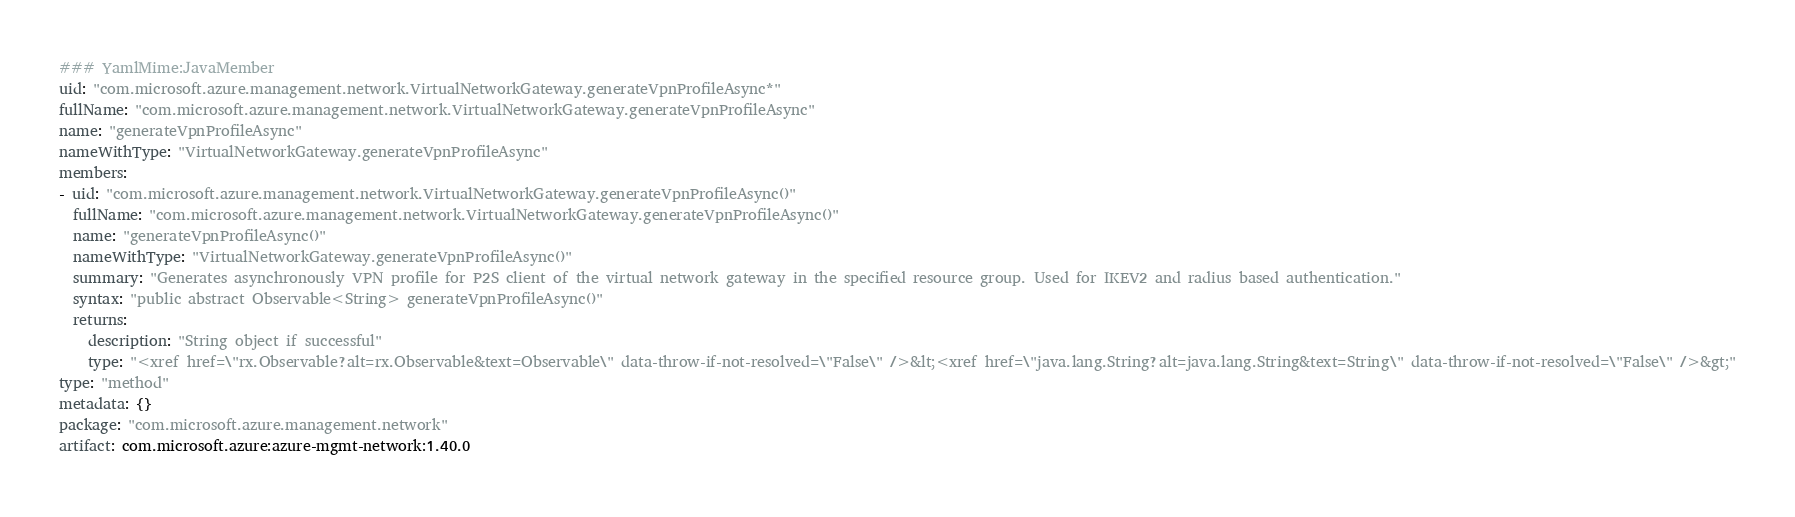<code> <loc_0><loc_0><loc_500><loc_500><_YAML_>### YamlMime:JavaMember
uid: "com.microsoft.azure.management.network.VirtualNetworkGateway.generateVpnProfileAsync*"
fullName: "com.microsoft.azure.management.network.VirtualNetworkGateway.generateVpnProfileAsync"
name: "generateVpnProfileAsync"
nameWithType: "VirtualNetworkGateway.generateVpnProfileAsync"
members:
- uid: "com.microsoft.azure.management.network.VirtualNetworkGateway.generateVpnProfileAsync()"
  fullName: "com.microsoft.azure.management.network.VirtualNetworkGateway.generateVpnProfileAsync()"
  name: "generateVpnProfileAsync()"
  nameWithType: "VirtualNetworkGateway.generateVpnProfileAsync()"
  summary: "Generates asynchronously VPN profile for P2S client of the virtual network gateway in the specified resource group. Used for IKEV2 and radius based authentication."
  syntax: "public abstract Observable<String> generateVpnProfileAsync()"
  returns:
    description: "String object if successful"
    type: "<xref href=\"rx.Observable?alt=rx.Observable&text=Observable\" data-throw-if-not-resolved=\"False\" />&lt;<xref href=\"java.lang.String?alt=java.lang.String&text=String\" data-throw-if-not-resolved=\"False\" />&gt;"
type: "method"
metadata: {}
package: "com.microsoft.azure.management.network"
artifact: com.microsoft.azure:azure-mgmt-network:1.40.0
</code> 